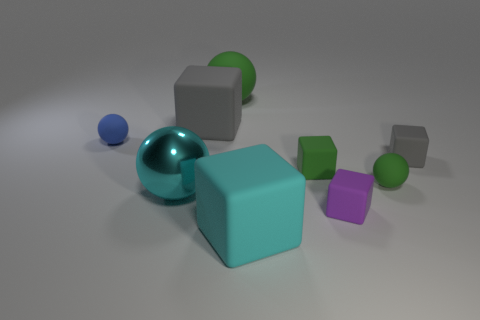What shape is the large green rubber thing?
Give a very brief answer. Sphere. Are there any tiny blue spheres in front of the big sphere that is in front of the rubber ball that is to the left of the cyan metal sphere?
Your response must be concise. No. What is the color of the tiny block in front of the large cyan thing behind the cyan thing that is in front of the cyan shiny sphere?
Give a very brief answer. Purple. What is the material of the cyan object that is the same shape as the big green matte object?
Provide a short and direct response. Metal. There is a sphere in front of the green matte ball to the right of the large cyan matte block; what is its size?
Your response must be concise. Large. There is a large sphere left of the large gray matte object; what is it made of?
Offer a very short reply. Metal. There is a cyan object that is the same material as the large green sphere; what size is it?
Your answer should be compact. Large. What number of small gray matte objects have the same shape as the small purple rubber object?
Your answer should be compact. 1. Do the tiny purple object and the large cyan object behind the small purple block have the same shape?
Your response must be concise. No. Are there any large red blocks that have the same material as the small green sphere?
Make the answer very short. No. 